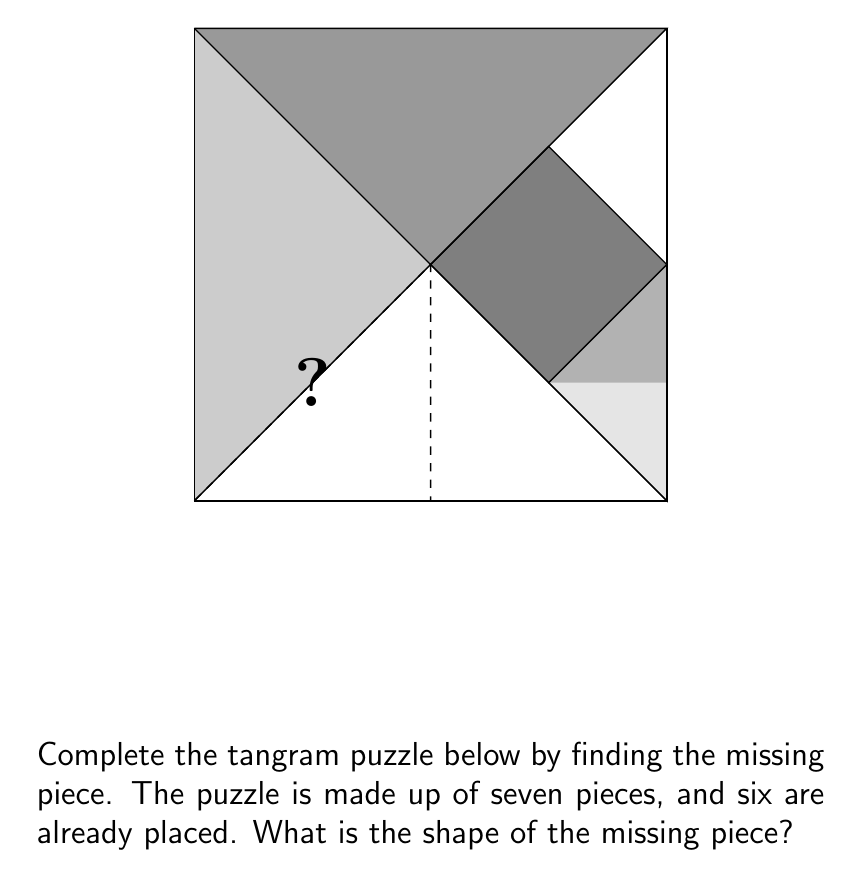Provide a solution to this math problem. To solve this problem, we need to analyze the given tangram puzzle and identify the shape of the missing piece. Let's follow these steps:

1. Observe the overall shape: The puzzle forms a square.

2. Count the visible pieces: We can see 6 pieces already placed.

3. Recall tangram rules: A standard tangram set consists of 7 pieces.

4. Identify the missing area: The empty space is in the bottom-left corner of the square.

5. Analyze the missing area's shape: It forms a right-angled triangle.

6. Determine the size: The missing piece takes up 1/8 of the total square area.

7. Compare with standard tangram pieces: The small triangle in a tangram set occupies 1/16 of the total area, while the medium triangle occupies 1/8.

8. Conclude: The missing piece must be a medium-sized right-angled triangle.

This solution doesn't require complex calculations, aligning with the nonchalant student persona who might prefer a more intuitive approach.
Answer: Medium right-angled triangle 